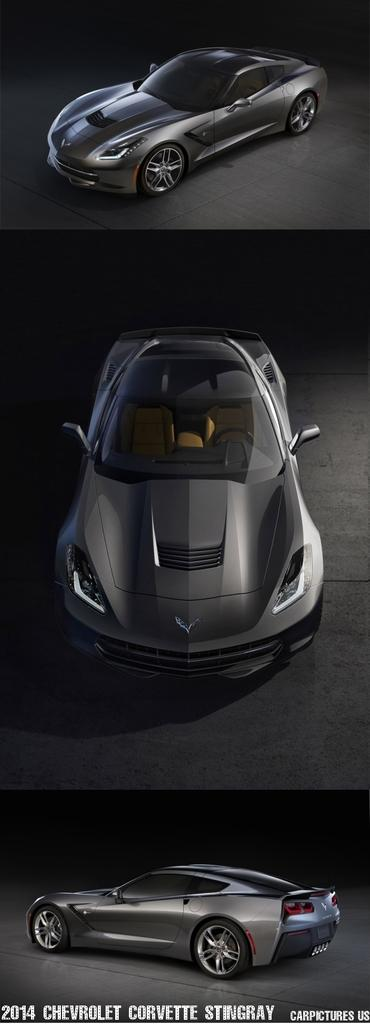What type of vehicles are in the image? There are cars in the image. Where are the cars located? The cars are on the floor. What can be found at the bottom of the image? There is text at the bottom of the image. What type of ray can be seen swimming under the cars in the image? There is no ray present in the image; it only features cars on the floor and text at the bottom. 